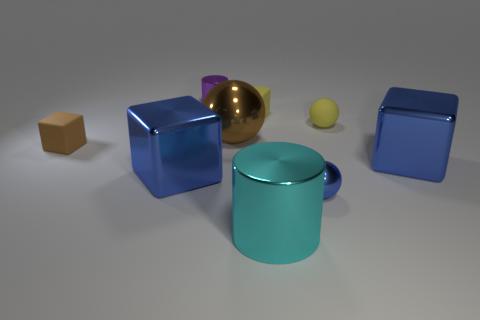Considering the colors in the image, what mood or feeling do you think this arrangement of objects is meant to evoke? The use of cool colors, like blues and the neutral background, combined with the orderly arrangement of objects, might evoke a feeling of calmness and order. The presence of reflective materials adds a touch of sophistication. The image seems designed to be aesthetically pleasant without conveying a strong emotional message, focusing on simplicity and balance. 